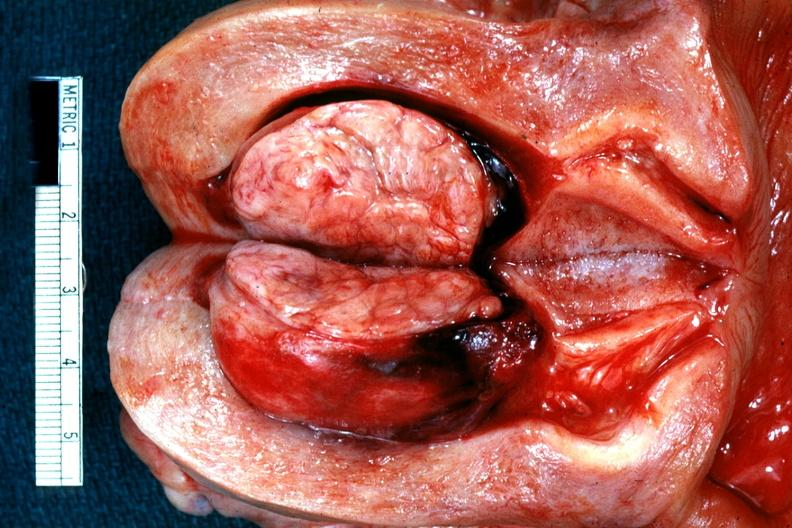what is present?
Answer the question using a single word or phrase. Uterus 